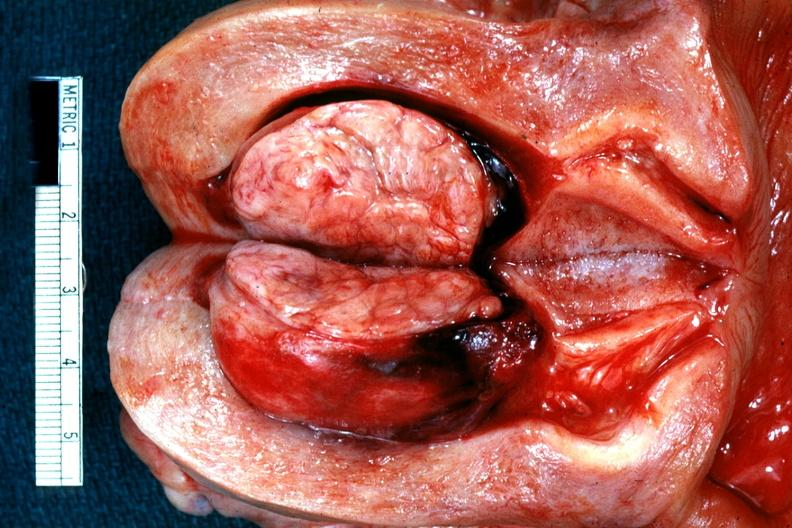what is present?
Answer the question using a single word or phrase. Uterus 